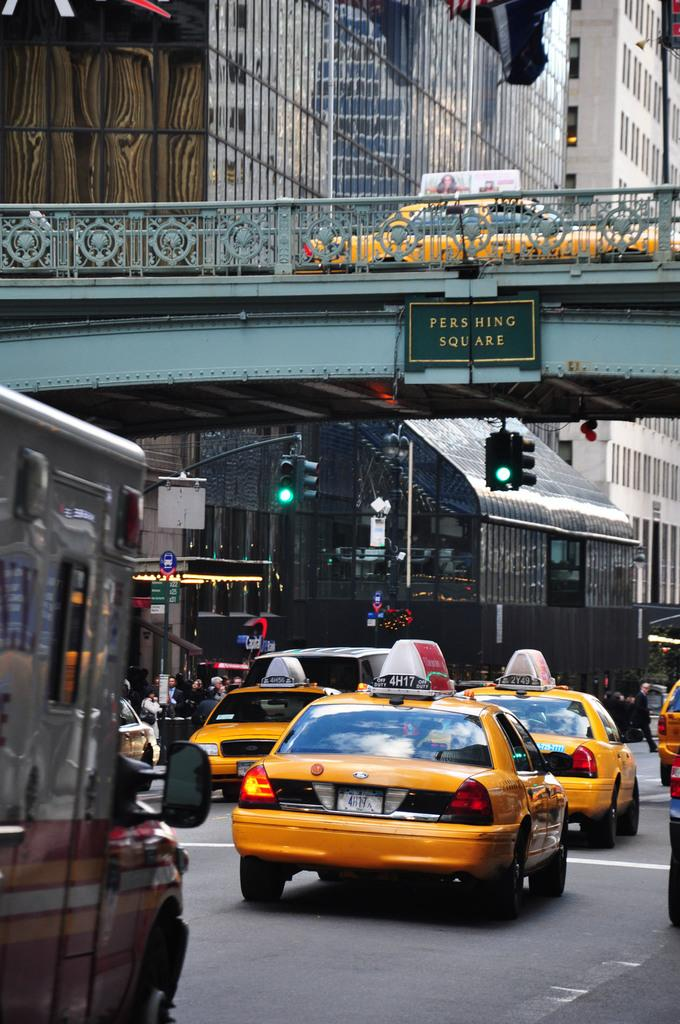Provide a one-sentence caption for the provided image. Three yellow taxi cab cars with signs on top in city limit. 